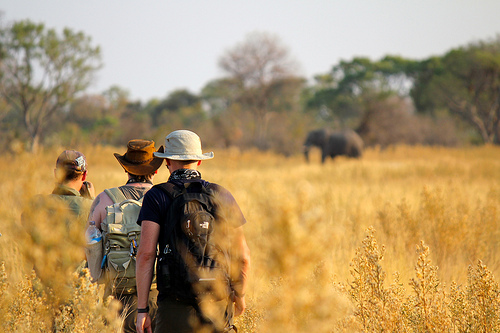The animal on the plain has what size? The animal on the plain is large. 